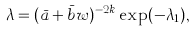Convert formula to latex. <formula><loc_0><loc_0><loc_500><loc_500>\lambda = ( \bar { a } + \bar { b } w ) ^ { - 2 k } \exp ( - \lambda _ { 1 } ) ,</formula> 